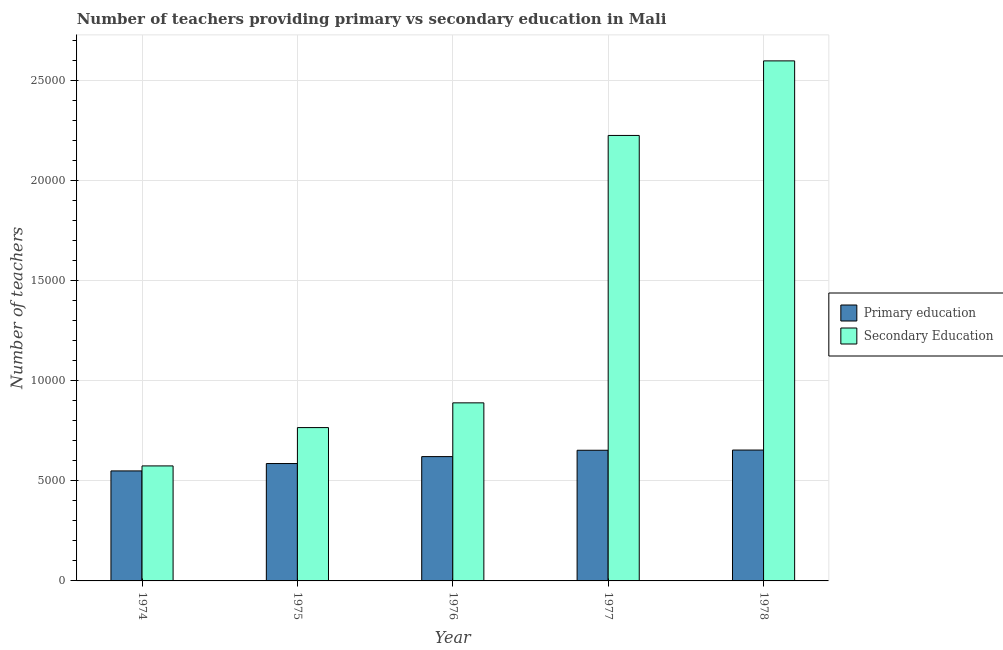How many different coloured bars are there?
Make the answer very short. 2. Are the number of bars per tick equal to the number of legend labels?
Your answer should be compact. Yes. Are the number of bars on each tick of the X-axis equal?
Offer a very short reply. Yes. How many bars are there on the 4th tick from the right?
Offer a terse response. 2. What is the label of the 1st group of bars from the left?
Give a very brief answer. 1974. What is the number of primary teachers in 1975?
Make the answer very short. 5866. Across all years, what is the maximum number of secondary teachers?
Give a very brief answer. 2.60e+04. Across all years, what is the minimum number of primary teachers?
Your answer should be compact. 5498. In which year was the number of primary teachers maximum?
Provide a short and direct response. 1978. In which year was the number of secondary teachers minimum?
Your answer should be very brief. 1974. What is the total number of secondary teachers in the graph?
Your answer should be very brief. 7.06e+04. What is the difference between the number of secondary teachers in 1975 and that in 1978?
Keep it short and to the point. -1.83e+04. What is the difference between the number of primary teachers in 1974 and the number of secondary teachers in 1977?
Keep it short and to the point. -1032. What is the average number of secondary teachers per year?
Your response must be concise. 1.41e+04. What is the ratio of the number of secondary teachers in 1975 to that in 1977?
Give a very brief answer. 0.34. Is the number of primary teachers in 1975 less than that in 1978?
Your answer should be compact. Yes. What is the difference between the highest and the second highest number of primary teachers?
Your answer should be compact. 10. What is the difference between the highest and the lowest number of secondary teachers?
Provide a succinct answer. 2.02e+04. What does the 1st bar from the left in 1978 represents?
Make the answer very short. Primary education. What does the 1st bar from the right in 1975 represents?
Offer a very short reply. Secondary Education. How many bars are there?
Provide a succinct answer. 10. Are all the bars in the graph horizontal?
Keep it short and to the point. No. What is the difference between two consecutive major ticks on the Y-axis?
Provide a succinct answer. 5000. Where does the legend appear in the graph?
Offer a terse response. Center right. What is the title of the graph?
Give a very brief answer. Number of teachers providing primary vs secondary education in Mali. Does "Non-residents" appear as one of the legend labels in the graph?
Your response must be concise. No. What is the label or title of the X-axis?
Your answer should be compact. Year. What is the label or title of the Y-axis?
Keep it short and to the point. Number of teachers. What is the Number of teachers in Primary education in 1974?
Keep it short and to the point. 5498. What is the Number of teachers in Secondary Education in 1974?
Ensure brevity in your answer.  5748. What is the Number of teachers of Primary education in 1975?
Provide a short and direct response. 5866. What is the Number of teachers in Secondary Education in 1975?
Offer a very short reply. 7663. What is the Number of teachers in Primary education in 1976?
Offer a very short reply. 6213. What is the Number of teachers in Secondary Education in 1976?
Your answer should be compact. 8899. What is the Number of teachers in Primary education in 1977?
Your answer should be compact. 6530. What is the Number of teachers of Secondary Education in 1977?
Offer a terse response. 2.23e+04. What is the Number of teachers in Primary education in 1978?
Keep it short and to the point. 6540. What is the Number of teachers in Secondary Education in 1978?
Make the answer very short. 2.60e+04. Across all years, what is the maximum Number of teachers in Primary education?
Give a very brief answer. 6540. Across all years, what is the maximum Number of teachers of Secondary Education?
Make the answer very short. 2.60e+04. Across all years, what is the minimum Number of teachers in Primary education?
Your answer should be very brief. 5498. Across all years, what is the minimum Number of teachers of Secondary Education?
Keep it short and to the point. 5748. What is the total Number of teachers of Primary education in the graph?
Provide a short and direct response. 3.06e+04. What is the total Number of teachers of Secondary Education in the graph?
Provide a succinct answer. 7.06e+04. What is the difference between the Number of teachers of Primary education in 1974 and that in 1975?
Offer a terse response. -368. What is the difference between the Number of teachers of Secondary Education in 1974 and that in 1975?
Offer a terse response. -1915. What is the difference between the Number of teachers in Primary education in 1974 and that in 1976?
Ensure brevity in your answer.  -715. What is the difference between the Number of teachers in Secondary Education in 1974 and that in 1976?
Your response must be concise. -3151. What is the difference between the Number of teachers in Primary education in 1974 and that in 1977?
Offer a terse response. -1032. What is the difference between the Number of teachers of Secondary Education in 1974 and that in 1977?
Make the answer very short. -1.65e+04. What is the difference between the Number of teachers of Primary education in 1974 and that in 1978?
Your response must be concise. -1042. What is the difference between the Number of teachers in Secondary Education in 1974 and that in 1978?
Your answer should be very brief. -2.02e+04. What is the difference between the Number of teachers in Primary education in 1975 and that in 1976?
Offer a very short reply. -347. What is the difference between the Number of teachers in Secondary Education in 1975 and that in 1976?
Make the answer very short. -1236. What is the difference between the Number of teachers in Primary education in 1975 and that in 1977?
Keep it short and to the point. -664. What is the difference between the Number of teachers in Secondary Education in 1975 and that in 1977?
Keep it short and to the point. -1.46e+04. What is the difference between the Number of teachers of Primary education in 1975 and that in 1978?
Give a very brief answer. -674. What is the difference between the Number of teachers of Secondary Education in 1975 and that in 1978?
Offer a terse response. -1.83e+04. What is the difference between the Number of teachers in Primary education in 1976 and that in 1977?
Offer a terse response. -317. What is the difference between the Number of teachers in Secondary Education in 1976 and that in 1977?
Keep it short and to the point. -1.34e+04. What is the difference between the Number of teachers of Primary education in 1976 and that in 1978?
Your answer should be compact. -327. What is the difference between the Number of teachers of Secondary Education in 1976 and that in 1978?
Provide a succinct answer. -1.71e+04. What is the difference between the Number of teachers in Primary education in 1977 and that in 1978?
Make the answer very short. -10. What is the difference between the Number of teachers of Secondary Education in 1977 and that in 1978?
Ensure brevity in your answer.  -3727. What is the difference between the Number of teachers of Primary education in 1974 and the Number of teachers of Secondary Education in 1975?
Give a very brief answer. -2165. What is the difference between the Number of teachers in Primary education in 1974 and the Number of teachers in Secondary Education in 1976?
Make the answer very short. -3401. What is the difference between the Number of teachers of Primary education in 1974 and the Number of teachers of Secondary Education in 1977?
Offer a very short reply. -1.68e+04. What is the difference between the Number of teachers of Primary education in 1974 and the Number of teachers of Secondary Education in 1978?
Offer a very short reply. -2.05e+04. What is the difference between the Number of teachers of Primary education in 1975 and the Number of teachers of Secondary Education in 1976?
Give a very brief answer. -3033. What is the difference between the Number of teachers in Primary education in 1975 and the Number of teachers in Secondary Education in 1977?
Keep it short and to the point. -1.64e+04. What is the difference between the Number of teachers in Primary education in 1975 and the Number of teachers in Secondary Education in 1978?
Give a very brief answer. -2.01e+04. What is the difference between the Number of teachers in Primary education in 1976 and the Number of teachers in Secondary Education in 1977?
Offer a terse response. -1.60e+04. What is the difference between the Number of teachers of Primary education in 1976 and the Number of teachers of Secondary Education in 1978?
Provide a succinct answer. -1.98e+04. What is the difference between the Number of teachers of Primary education in 1977 and the Number of teachers of Secondary Education in 1978?
Provide a succinct answer. -1.95e+04. What is the average Number of teachers of Primary education per year?
Offer a terse response. 6129.4. What is the average Number of teachers of Secondary Education per year?
Offer a very short reply. 1.41e+04. In the year 1974, what is the difference between the Number of teachers of Primary education and Number of teachers of Secondary Education?
Provide a short and direct response. -250. In the year 1975, what is the difference between the Number of teachers in Primary education and Number of teachers in Secondary Education?
Provide a succinct answer. -1797. In the year 1976, what is the difference between the Number of teachers in Primary education and Number of teachers in Secondary Education?
Your answer should be compact. -2686. In the year 1977, what is the difference between the Number of teachers in Primary education and Number of teachers in Secondary Education?
Ensure brevity in your answer.  -1.57e+04. In the year 1978, what is the difference between the Number of teachers in Primary education and Number of teachers in Secondary Education?
Your answer should be very brief. -1.94e+04. What is the ratio of the Number of teachers of Primary education in 1974 to that in 1975?
Make the answer very short. 0.94. What is the ratio of the Number of teachers of Secondary Education in 1974 to that in 1975?
Keep it short and to the point. 0.75. What is the ratio of the Number of teachers of Primary education in 1974 to that in 1976?
Offer a terse response. 0.88. What is the ratio of the Number of teachers in Secondary Education in 1974 to that in 1976?
Make the answer very short. 0.65. What is the ratio of the Number of teachers of Primary education in 1974 to that in 1977?
Make the answer very short. 0.84. What is the ratio of the Number of teachers in Secondary Education in 1974 to that in 1977?
Your answer should be very brief. 0.26. What is the ratio of the Number of teachers in Primary education in 1974 to that in 1978?
Offer a very short reply. 0.84. What is the ratio of the Number of teachers in Secondary Education in 1974 to that in 1978?
Your answer should be compact. 0.22. What is the ratio of the Number of teachers in Primary education in 1975 to that in 1976?
Provide a short and direct response. 0.94. What is the ratio of the Number of teachers of Secondary Education in 1975 to that in 1976?
Provide a short and direct response. 0.86. What is the ratio of the Number of teachers in Primary education in 1975 to that in 1977?
Your response must be concise. 0.9. What is the ratio of the Number of teachers in Secondary Education in 1975 to that in 1977?
Give a very brief answer. 0.34. What is the ratio of the Number of teachers of Primary education in 1975 to that in 1978?
Offer a terse response. 0.9. What is the ratio of the Number of teachers of Secondary Education in 1975 to that in 1978?
Keep it short and to the point. 0.29. What is the ratio of the Number of teachers in Primary education in 1976 to that in 1977?
Make the answer very short. 0.95. What is the ratio of the Number of teachers of Secondary Education in 1976 to that in 1977?
Ensure brevity in your answer.  0.4. What is the ratio of the Number of teachers in Secondary Education in 1976 to that in 1978?
Provide a short and direct response. 0.34. What is the ratio of the Number of teachers of Primary education in 1977 to that in 1978?
Keep it short and to the point. 1. What is the ratio of the Number of teachers of Secondary Education in 1977 to that in 1978?
Your answer should be compact. 0.86. What is the difference between the highest and the second highest Number of teachers of Secondary Education?
Offer a very short reply. 3727. What is the difference between the highest and the lowest Number of teachers in Primary education?
Give a very brief answer. 1042. What is the difference between the highest and the lowest Number of teachers of Secondary Education?
Your answer should be very brief. 2.02e+04. 